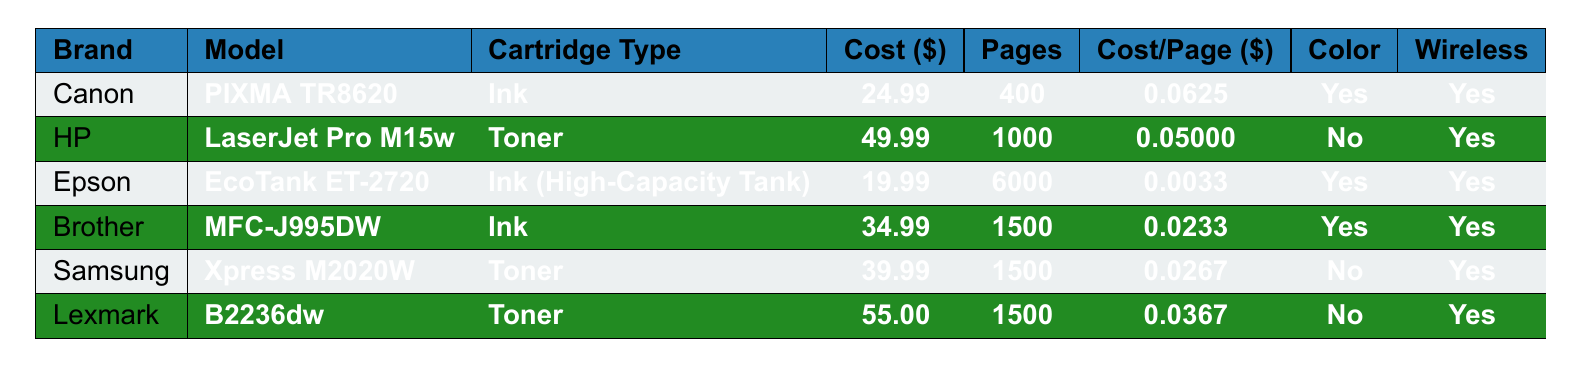What is the cost of the Epson EcoTank ET-2720 cartridge? In the table, the row for the Epson EcoTank ET-2720 shows that the cost per cartridge is listed as $19.99.
Answer: 19.99 Which printer has the lowest cost per page for color printing? The Canon PIXMA TR8620 has a cost per page of $0.0625, and the Brother MFC-J995DW has a cost per page of $0.0233. Since both support color printing, we compare their costs: Brother is cheaper.
Answer: Brother MFC-J995DW What is the page yield of the Canon PIXMA TR8620? By examining the row for the Canon PIXMA TR8620, the page yield is stated as 400 pages.
Answer: 400 Is the HP LaserJet Pro M15w capable of wireless printing? The table indicates that the HP LaserJet Pro M15w has "Yes" listed under the Wireless Printing column.
Answer: Yes What is the average cost per cartridge for all listed printers? The costs per cartridge are 24.99, 49.99, 19.99, 34.99, 39.99, and 55.00. Summing these gives 24.99 + 49.99 + 19.99 + 34.99 + 39.99 + 55.00 = 224.95. Dividing by the number of printers (6) gives 224.95 / 6 = 37.49.
Answer: 37.49 Which printer has the highest page yield? Looking at the data, the Epson EcoTank ET-2720 has a page yield of 6000, which is higher than any other printer listed.
Answer: Epson EcoTank ET-2720 If I want a wireless printer that only does color printing, which models can I consider? The table shows that the Canon PIXMA TR8620 and Brother MFC-J995DW have "Yes" under both Color Printing and Wireless Printing. These are the options available.
Answer: Canon PIXMA TR8620, Brother MFC-J995DW What is the difference in cost per page between HP LaserJet Pro M15w and Samsung Xpress M2020W? HP LaserJet Pro M15w has a cost per page of $0.04999, and Samsung Xpress M2020W has a cost per page of $0.0267. The difference is $0.04999 - $0.0267 = $0.02329.
Answer: 0.02329 Are there any printers in the data that do not support color printing? Both the HP LaserJet Pro M15w and Samsung Xpress M2020W are marked "No" for Color Printing in the table. Thus, these two do not support color printing.
Answer: Yes What is the total combined cost for replacing cartridges of both Brother and Lexmark printers? The Brother MFC-J995DW costs $34.99 and the Lexmark B2236dw costs $55.00. Adding these gives $34.99 + $55 = $89.99.
Answer: 89.99 